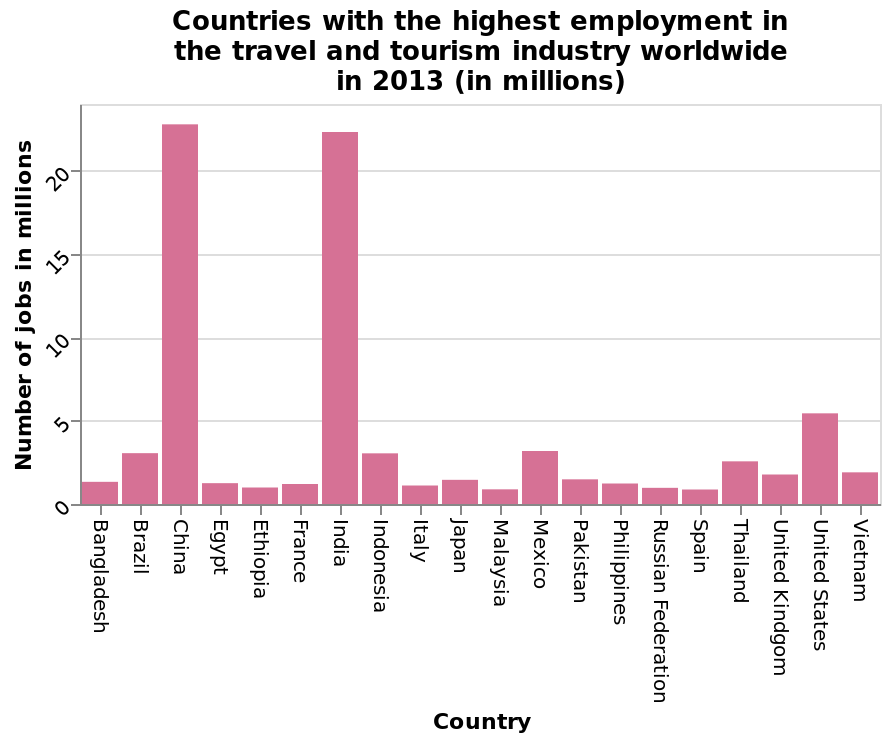<image>
Are all the other countries similar in terms of employment?  Yes, all the other countries are very similar in terms of employment. What does the x-axis measure in the bar diagram? The x-axis of the bar diagram measures the countries. 